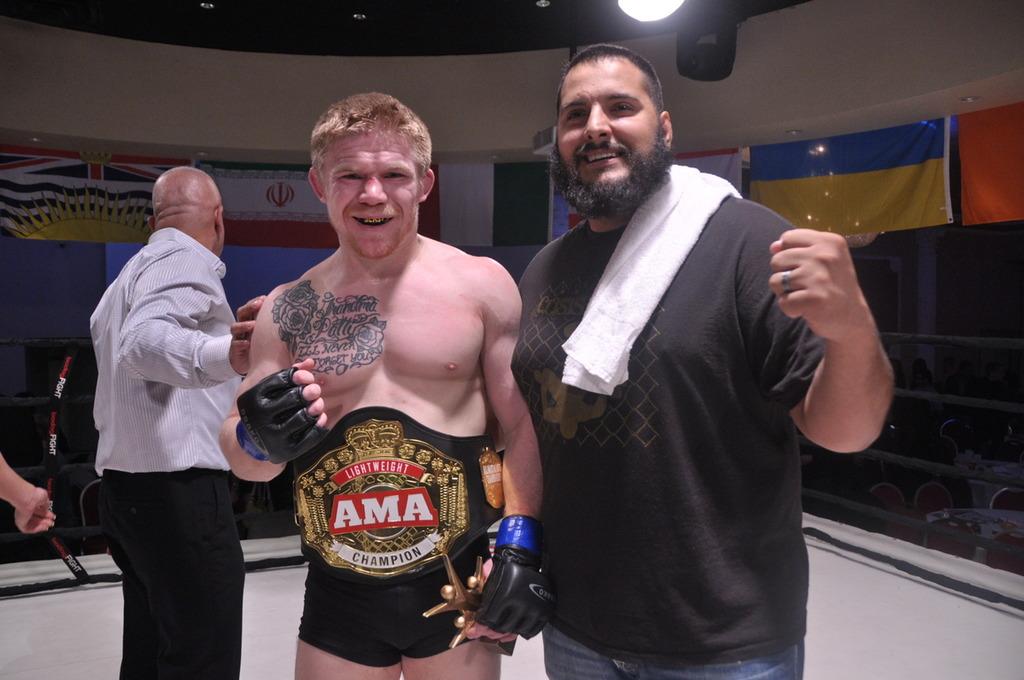What kind of champion is he?
Make the answer very short. Ama. What organization is this person the lightweight champion of?
Make the answer very short. Ama. 